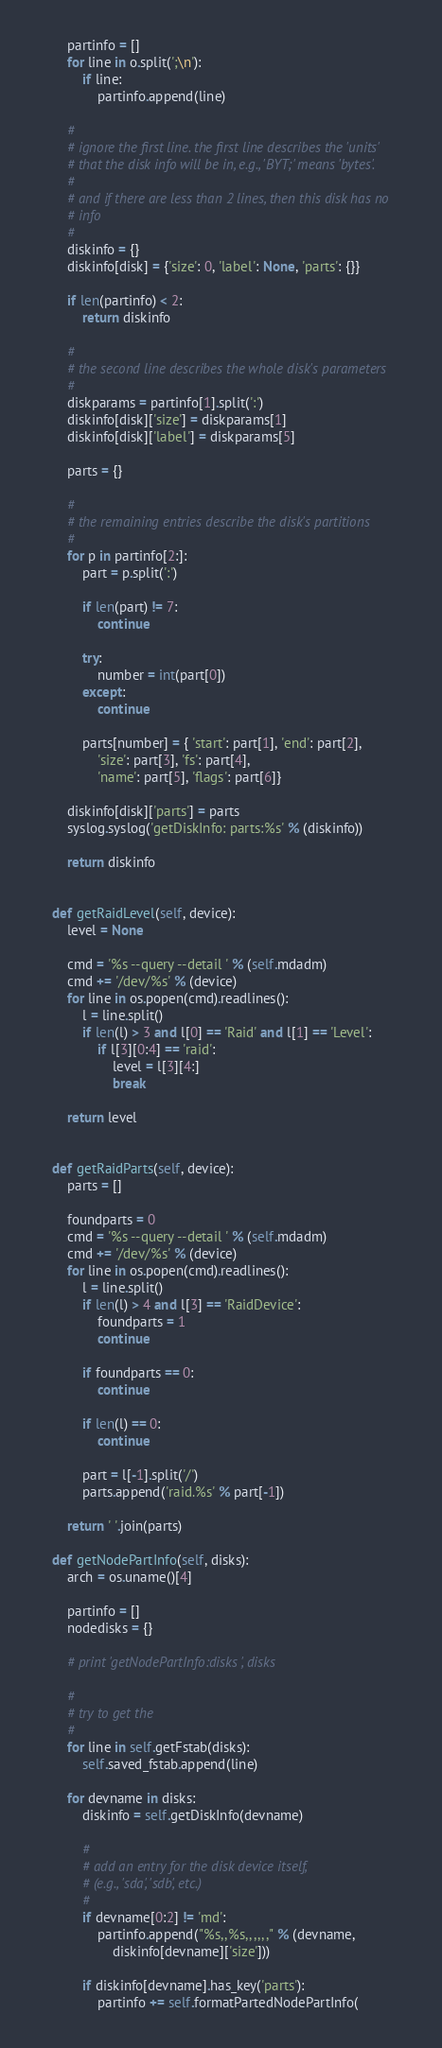Convert code to text. <code><loc_0><loc_0><loc_500><loc_500><_Python_>
		partinfo = []
		for line in o.split(';\n'):
			if line:
				partinfo.append(line)

		#
		# ignore the first line. the first line describes the 'units'
		# that the disk info will be in, e.g., 'BYT;' means 'bytes'.
		#
		# and if there are less than 2 lines, then this disk has no
		# info
		#
		diskinfo = {}
		diskinfo[disk] = {'size': 0, 'label': None, 'parts': {}}

		if len(partinfo) < 2:
			return diskinfo

		#
		# the second line describes the whole disk's parameters
		#
		diskparams = partinfo[1].split(':')
		diskinfo[disk]['size'] = diskparams[1]
		diskinfo[disk]['label'] = diskparams[5]

		parts = {}

		#
		# the remaining entries describe the disk's partitions
		#
		for p in partinfo[2:]:
			part = p.split(':')

			if len(part) != 7:
				continue

			try:
				number = int(part[0])
			except:
				continue

			parts[number] = { 'start': part[1], 'end': part[2],
				'size': part[3], 'fs': part[4],
				'name': part[5], 'flags': part[6]}

		diskinfo[disk]['parts'] = parts
		syslog.syslog('getDiskInfo: parts:%s' % (diskinfo))

		return diskinfo


	def getRaidLevel(self, device):
		level = None

		cmd = '%s --query --detail ' % (self.mdadm)
		cmd += '/dev/%s' % (device)
		for line in os.popen(cmd).readlines():
			l = line.split()
			if len(l) > 3 and l[0] == 'Raid' and l[1] == 'Level':
				if l[3][0:4] == 'raid':
					level = l[3][4:]
					break
		
		return level


	def getRaidParts(self, device):
		parts = []

		foundparts = 0
		cmd = '%s --query --detail ' % (self.mdadm)
		cmd += '/dev/%s' % (device)
		for line in os.popen(cmd).readlines():
			l = line.split()
			if len(l) > 4 and l[3] == 'RaidDevice':
				foundparts = 1
				continue

			if foundparts == 0:
				continue

			if len(l) == 0:
				continue
			
			part = l[-1].split('/')
			parts.append('raid.%s' % part[-1])

		return ' '.join(parts)

	def getNodePartInfo(self, disks):
		arch = os.uname()[4]

		partinfo = []
		nodedisks = {}

		# print 'getNodePartInfo:disks ', disks

		#
		# try to get the 
		#
		for line in self.getFstab(disks):
			self.saved_fstab.append(line)

		for devname in disks:
			diskinfo = self.getDiskInfo(devname)

			#
			# add an entry for the disk device itself,
			# (e.g., 'sda', 'sdb', etc.)
			#
			if devname[0:2] != 'md':
				partinfo.append("%s,,%s,,,,,," % (devname,
					diskinfo[devname]['size']))

			if diskinfo[devname].has_key('parts'):
				partinfo += self.formatPartedNodePartInfo(</code> 